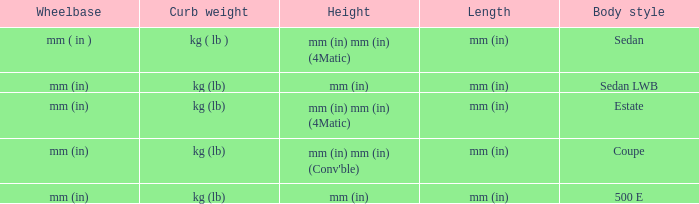What's the length of the model with Sedan body style? Mm (in). Help me parse the entirety of this table. {'header': ['Wheelbase', 'Curb weight', 'Height', 'Length', 'Body style'], 'rows': [['mm ( in )', 'kg ( lb )', 'mm (in) mm (in) (4Matic)', 'mm (in)', 'Sedan'], ['mm (in)', 'kg (lb)', 'mm (in)', 'mm (in)', 'Sedan LWB'], ['mm (in)', 'kg (lb)', 'mm (in) mm (in) (4Matic)', 'mm (in)', 'Estate'], ['mm (in)', 'kg (lb)', "mm (in) mm (in) (Conv'ble)", 'mm (in)', 'Coupe'], ['mm (in)', 'kg (lb)', 'mm (in)', 'mm (in)', '500 E']]} 